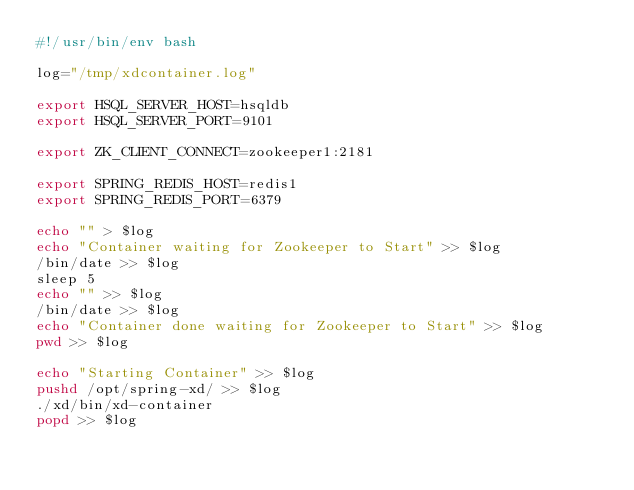Convert code to text. <code><loc_0><loc_0><loc_500><loc_500><_Bash_>#!/usr/bin/env bash

log="/tmp/xdcontainer.log"

export HSQL_SERVER_HOST=hsqldb
export HSQL_SERVER_PORT=9101

export ZK_CLIENT_CONNECT=zookeeper1:2181

export SPRING_REDIS_HOST=redis1
export SPRING_REDIS_PORT=6379

echo "" > $log
echo "Container waiting for Zookeeper to Start" >> $log
/bin/date >> $log
sleep 5
echo "" >> $log
/bin/date >> $log
echo "Container done waiting for Zookeeper to Start" >> $log
pwd >> $log

echo "Starting Container" >> $log
pushd /opt/spring-xd/ >> $log
./xd/bin/xd-container 
popd >> $log

</code> 